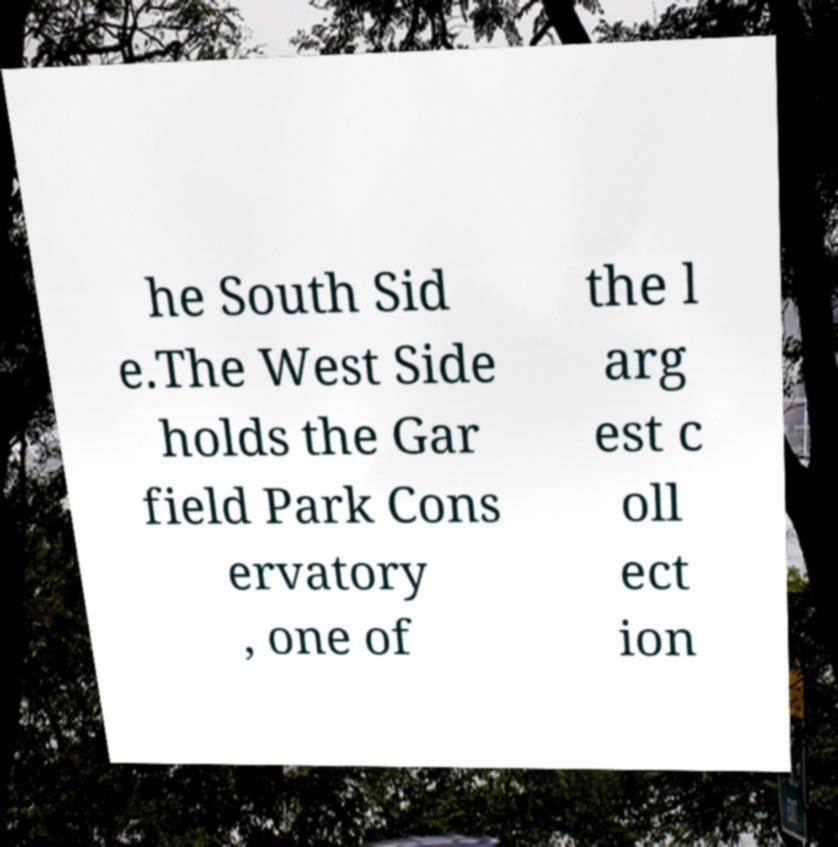For documentation purposes, I need the text within this image transcribed. Could you provide that? he South Sid e.The West Side holds the Gar field Park Cons ervatory , one of the l arg est c oll ect ion 